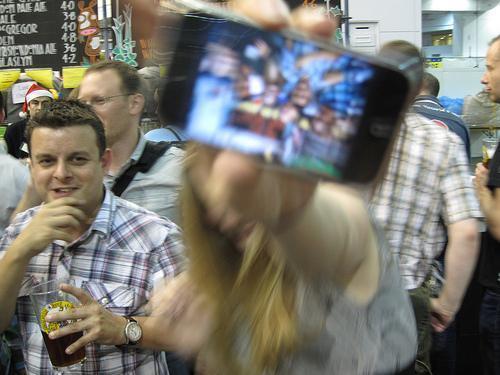How many people are wearing santa claus's hat?
Give a very brief answer. 1. 